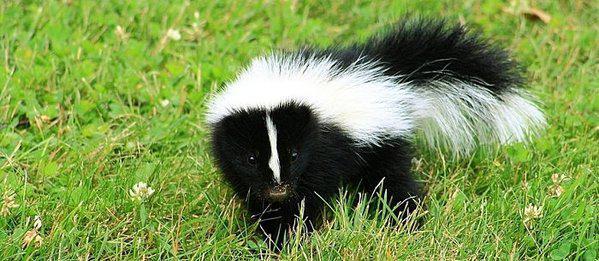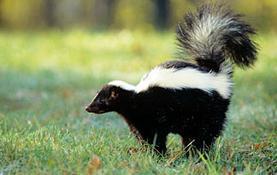The first image is the image on the left, the second image is the image on the right. Evaluate the accuracy of this statement regarding the images: "Both skunks are facing right.". Is it true? Answer yes or no. No. The first image is the image on the left, the second image is the image on the right. Given the left and right images, does the statement "there is a skunk in the grass with dandelions growing in the grass" hold true? Answer yes or no. No. 